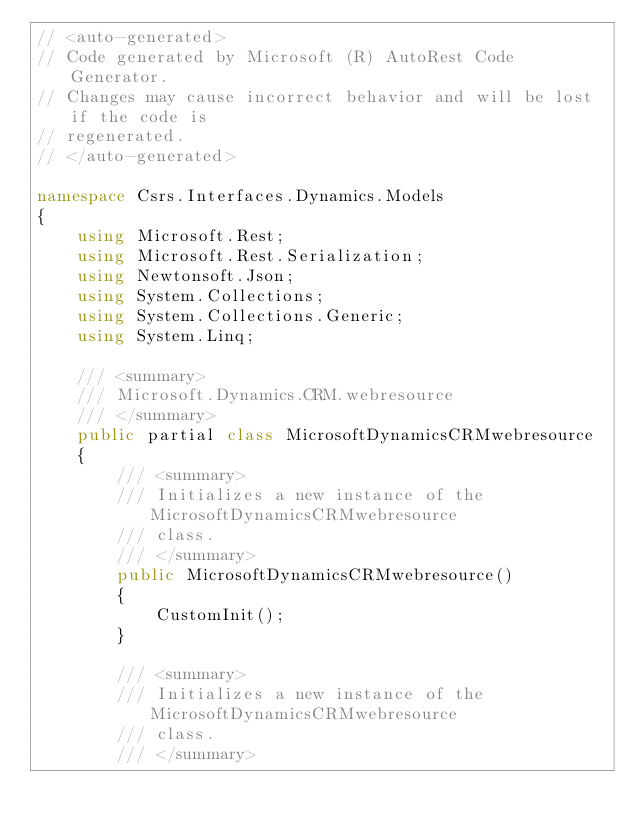Convert code to text. <code><loc_0><loc_0><loc_500><loc_500><_C#_>// <auto-generated>
// Code generated by Microsoft (R) AutoRest Code Generator.
// Changes may cause incorrect behavior and will be lost if the code is
// regenerated.
// </auto-generated>

namespace Csrs.Interfaces.Dynamics.Models
{
    using Microsoft.Rest;
    using Microsoft.Rest.Serialization;
    using Newtonsoft.Json;
    using System.Collections;
    using System.Collections.Generic;
    using System.Linq;

    /// <summary>
    /// Microsoft.Dynamics.CRM.webresource
    /// </summary>
    public partial class MicrosoftDynamicsCRMwebresource
    {
        /// <summary>
        /// Initializes a new instance of the MicrosoftDynamicsCRMwebresource
        /// class.
        /// </summary>
        public MicrosoftDynamicsCRMwebresource()
        {
            CustomInit();
        }

        /// <summary>
        /// Initializes a new instance of the MicrosoftDynamicsCRMwebresource
        /// class.
        /// </summary></code> 